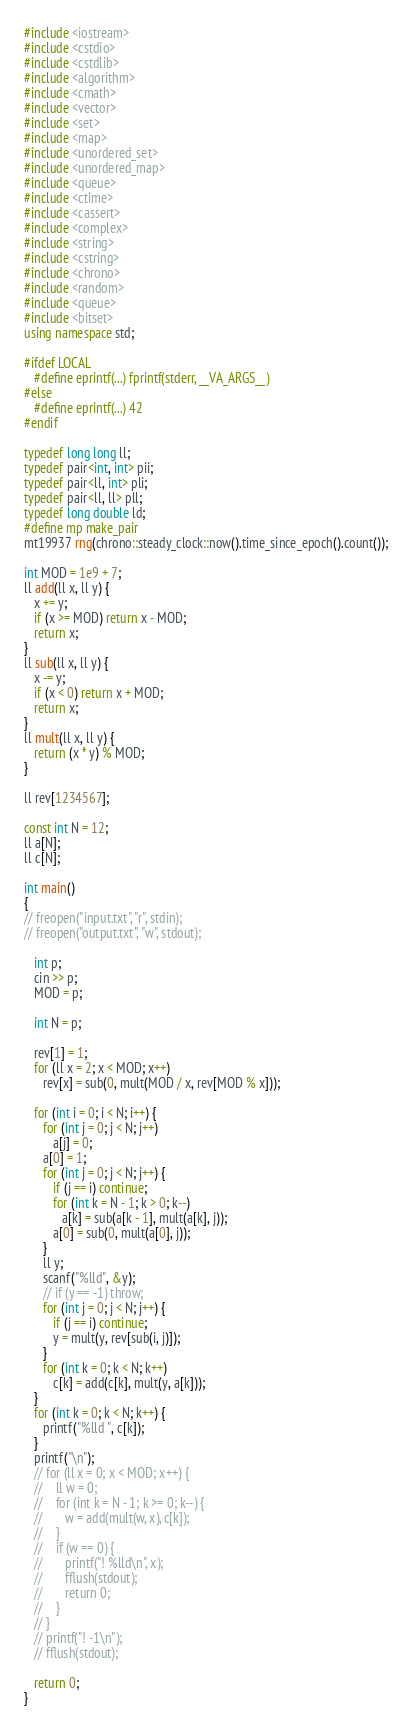Convert code to text. <code><loc_0><loc_0><loc_500><loc_500><_C++_>#include <iostream>
#include <cstdio>
#include <cstdlib>
#include <algorithm>
#include <cmath>
#include <vector>
#include <set>
#include <map>
#include <unordered_set>
#include <unordered_map>
#include <queue>
#include <ctime>
#include <cassert>
#include <complex>
#include <string>
#include <cstring>
#include <chrono>
#include <random>
#include <queue>
#include <bitset>
using namespace std;
 
#ifdef LOCAL
   #define eprintf(...) fprintf(stderr, __VA_ARGS__)
#else
   #define eprintf(...) 42
#endif
 
typedef long long ll;
typedef pair<int, int> pii;
typedef pair<ll, int> pli;
typedef pair<ll, ll> pll;
typedef long double ld;
#define mp make_pair
mt19937 rng(chrono::steady_clock::now().time_since_epoch().count());

int MOD = 1e9 + 7; 
ll add(ll x, ll y) {
   x += y;
   if (x >= MOD) return x - MOD;
   return x;
}
ll sub(ll x, ll y) {
   x -= y;
   if (x < 0) return x + MOD;
   return x;
}
ll mult(ll x, ll y) {
   return (x * y) % MOD;
}
 
ll rev[1234567];
 
const int N = 12;
ll a[N];
ll c[N];
 
int main()
{
// freopen("input.txt", "r", stdin);
// freopen("output.txt", "w", stdout);
      
   int p;
   cin >> p;
   MOD = p;

   int N = p;

   rev[1] = 1;
   for (ll x = 2; x < MOD; x++)
      rev[x] = sub(0, mult(MOD / x, rev[MOD % x]));
 
   for (int i = 0; i < N; i++) {
      for (int j = 0; j < N; j++)
         a[j] = 0;
      a[0] = 1;
      for (int j = 0; j < N; j++) {
         if (j == i) continue;
         for (int k = N - 1; k > 0; k--)
            a[k] = sub(a[k - 1], mult(a[k], j));
         a[0] = sub(0, mult(a[0], j));
      }
      ll y;
      scanf("%lld", &y);
      // if (y == -1) throw;
      for (int j = 0; j < N; j++) {
         if (j == i) continue;
         y = mult(y, rev[sub(i, j)]);
      }
      for (int k = 0; k < N; k++)
         c[k] = add(c[k], mult(y, a[k]));
   }
   for (int k = 0; k < N; k++) {
      printf("%lld ", c[k]);
   }
   printf("\n");
   // for (ll x = 0; x < MOD; x++) {
   //    ll w = 0;
   //    for (int k = N - 1; k >= 0; k--) {
   //       w = add(mult(w, x), c[k]);
   //    }
   //    if (w == 0) {
   //       printf("! %lld\n", x);
   //       fflush(stdout);
   //       return 0;
   //    }
   // }
   // printf("! -1\n");
   // fflush(stdout);
 
   return 0;
}
</code> 